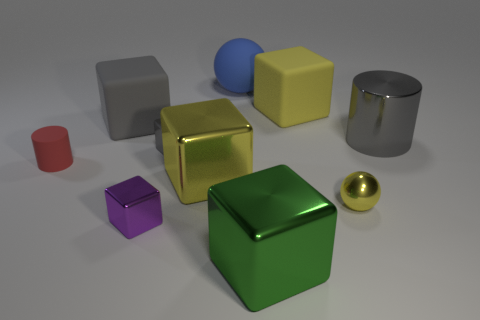Subtract all blue cylinders. How many gray blocks are left? 2 Subtract all big gray rubber blocks. How many blocks are left? 5 Subtract 1 cylinders. How many cylinders are left? 1 Subtract all spheres. How many objects are left? 8 Subtract all gray blocks. How many blocks are left? 4 Add 9 large gray cylinders. How many large gray cylinders exist? 10 Subtract 0 purple cylinders. How many objects are left? 10 Subtract all yellow cylinders. Subtract all gray blocks. How many cylinders are left? 2 Subtract all big yellow cubes. Subtract all gray cylinders. How many objects are left? 7 Add 8 small purple shiny cubes. How many small purple shiny cubes are left? 9 